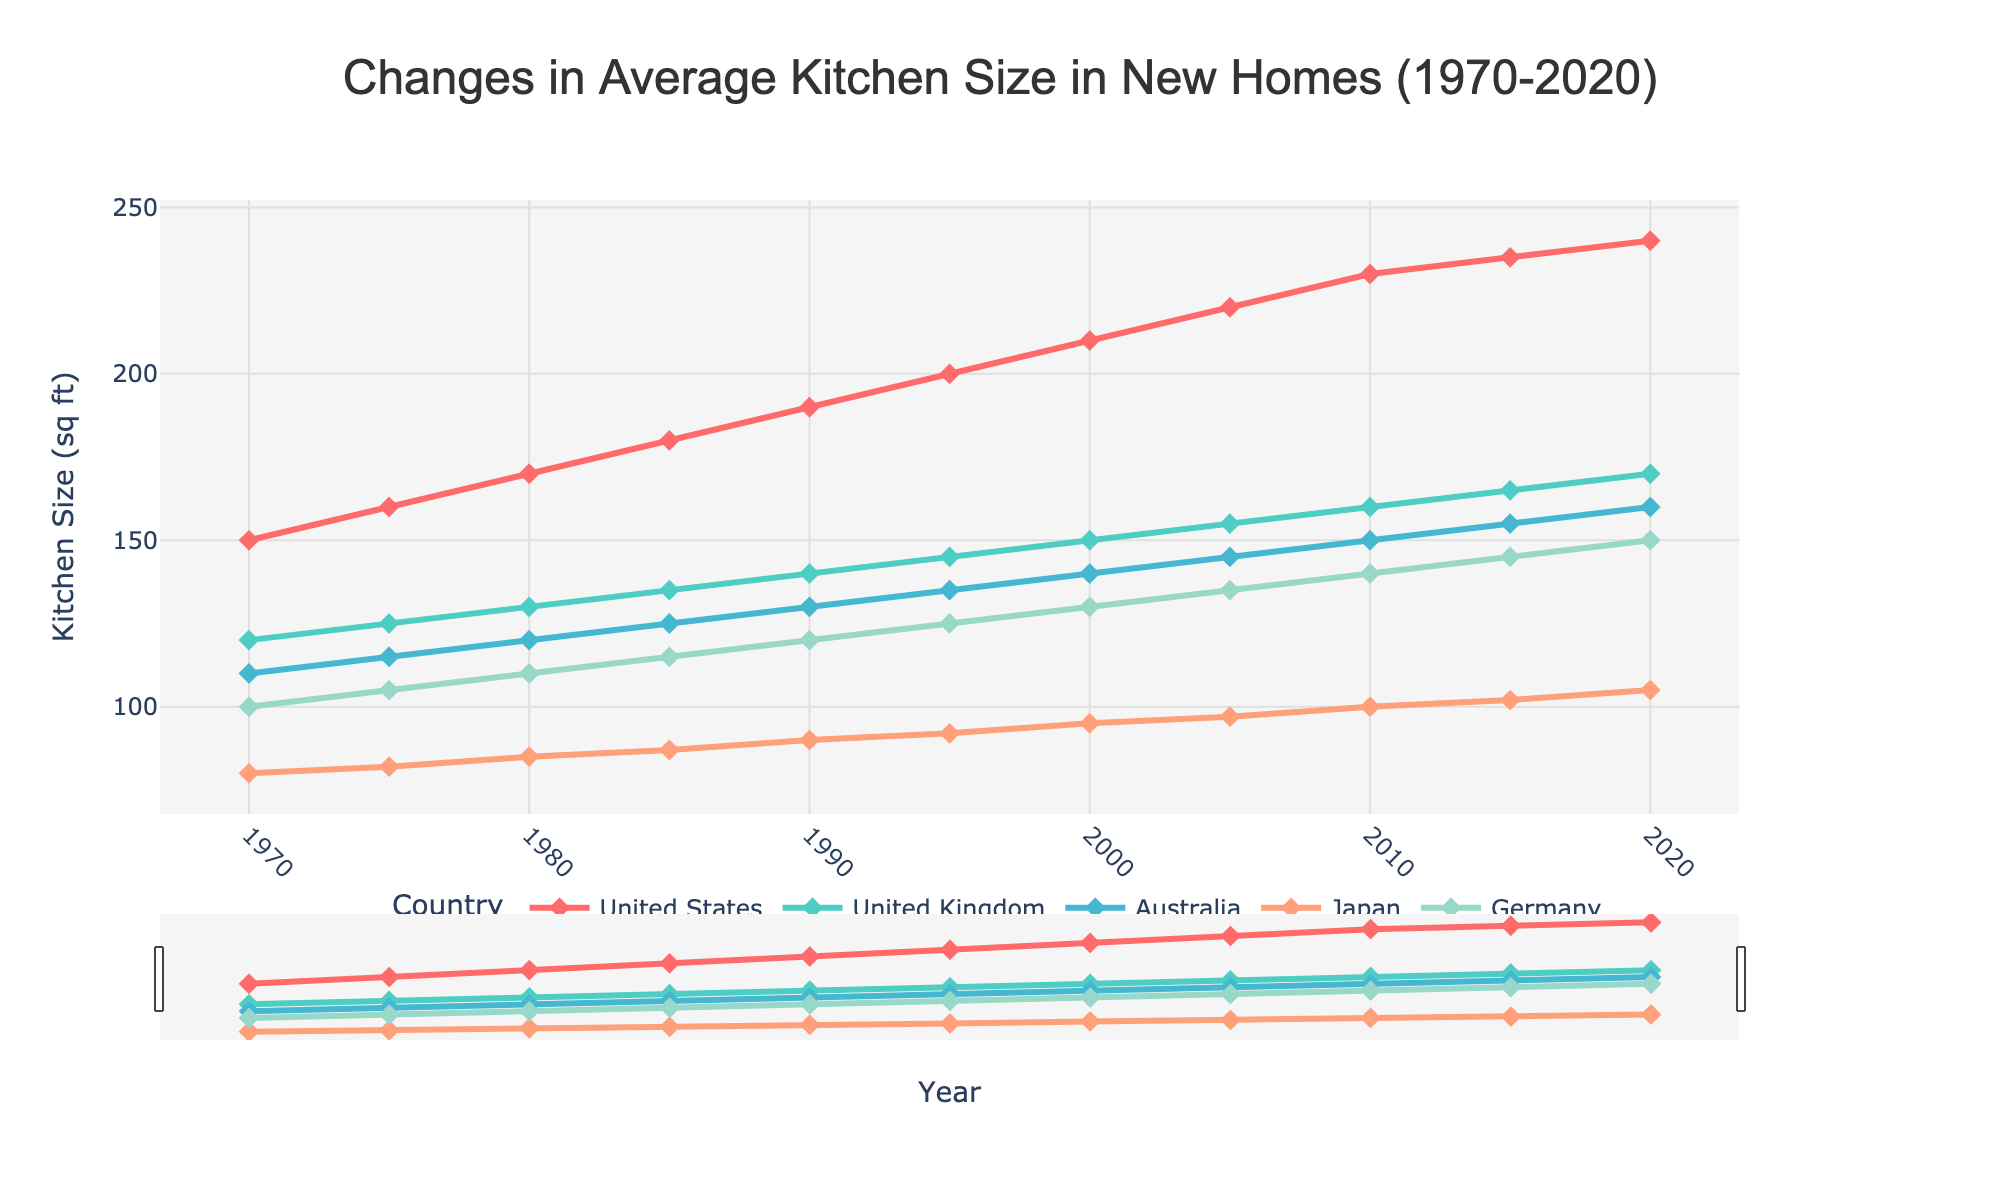What year did the United States' average kitchen size first surpass 200 square feet? Check the line representing the United States and observe when it first exceeds the 200 square feet mark. The year is 1995.
Answer: 1995 Which country had the smallest average kitchen size in 2020? Examine the final data points in 2020 for all countries; Japan has the smallest value of 105 square feet.
Answer: Japan How much did the average kitchen size in Germany increase from 1980 to 2000? Subtract the 1980 average size (110 sq ft) from the 2000 average size (130 sq ft); 130 - 110 = 20 square feet increase.
Answer: 20 sq ft Between which consecutive years did the United Kingdom see the largest increase in average kitchen size? Evaluate the differences between consecutive years for the UK, and the largest increase is between 2015 and 2020 (5 sq ft increase, from 165 to 170).
Answer: 2015 and 2020 Compare the average kitchen size in Australia and Japan in 1990. Which was larger and by how much? In 1990, Australia had 130 sq ft and Japan had 90 sq ft. Subtract 90 from 130 to find the difference (130 - 90 = 40). Australia was larger by 40 square feet.
Answer: Australia, 40 sq ft What is the average kitchen size in new homes for Germany over the entire period (from 1970 to 2020)? Sum Germany's average kitchen sizes for all years (100 + 105 + 110 + 115 + 120 + 125 + 130 + 135 + 140 + 145 + 150 = 1375). Divide by the number of years (1375 / 11 = 125).
Answer: 125 sq ft Identify the two countries with the most similar average kitchen sizes in 1985 and how similar they were. In 1985, Australia has 125 sq ft and Germany has 115 sq ft. Check other pairs, and the closest difference is between Australia (125) and United Kingdom (135), which is 10 sq ft.
Answer: Australia and United Kingdom, 10 sq ft How much did the average kitchen size in new homes change in the United States from 1970 to 2020? Subtract the value in 1970 (150 sq ft) from the value in 2020 (240 sq ft); 240 - 150 = 90 square feet increase.
Answer: 90 sq ft Which country shows the most consistent increase in average kitchen size over time? Evaluating the trend lines, the United States shows the most consistent (linear) increase, with no decreases.
Answer: United States 